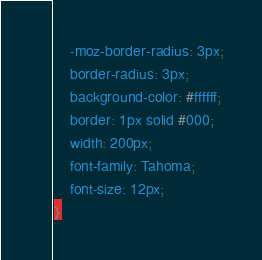<code> <loc_0><loc_0><loc_500><loc_500><_CSS_>    -moz-border-radius: 3px;
    border-radius: 3px;
    background-color: #ffffff;
    border: 1px solid #000;
    width: 200px;
    font-family: Tahoma;
    font-size: 12px;
}</code> 